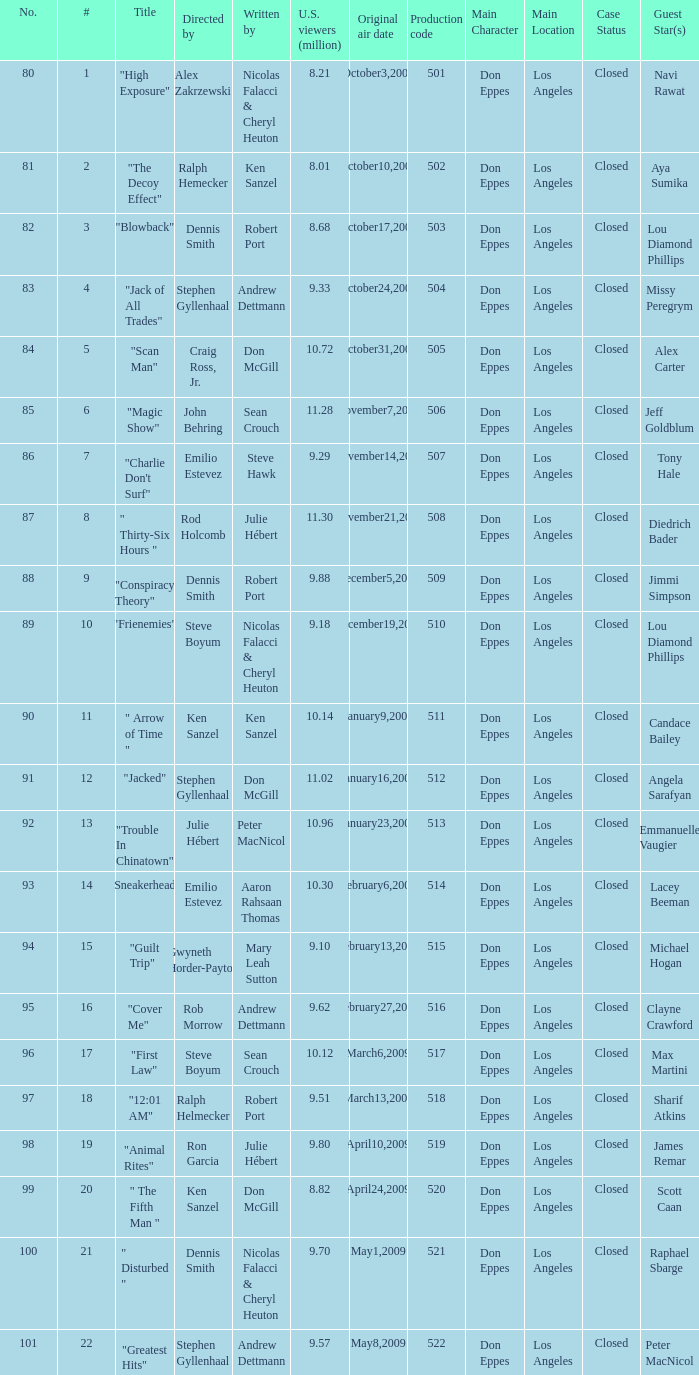What episode had 10.14 million viewers (U.S.)? 11.0. 